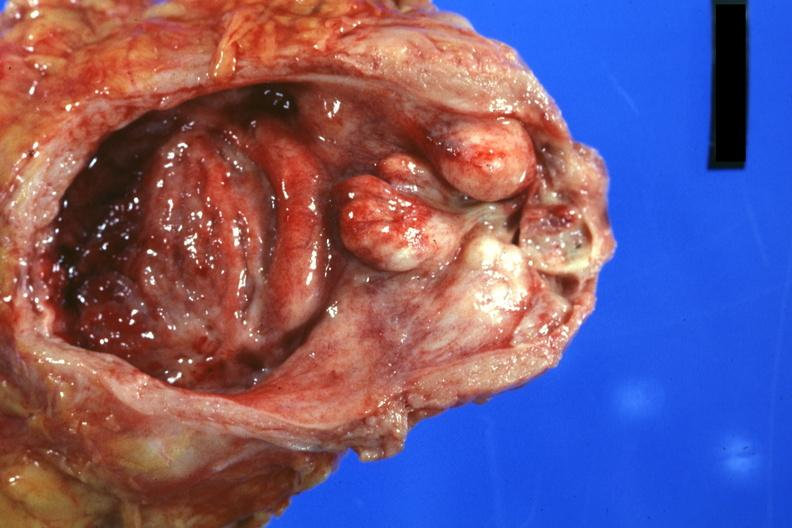what is present?
Answer the question using a single word or phrase. Prostate 